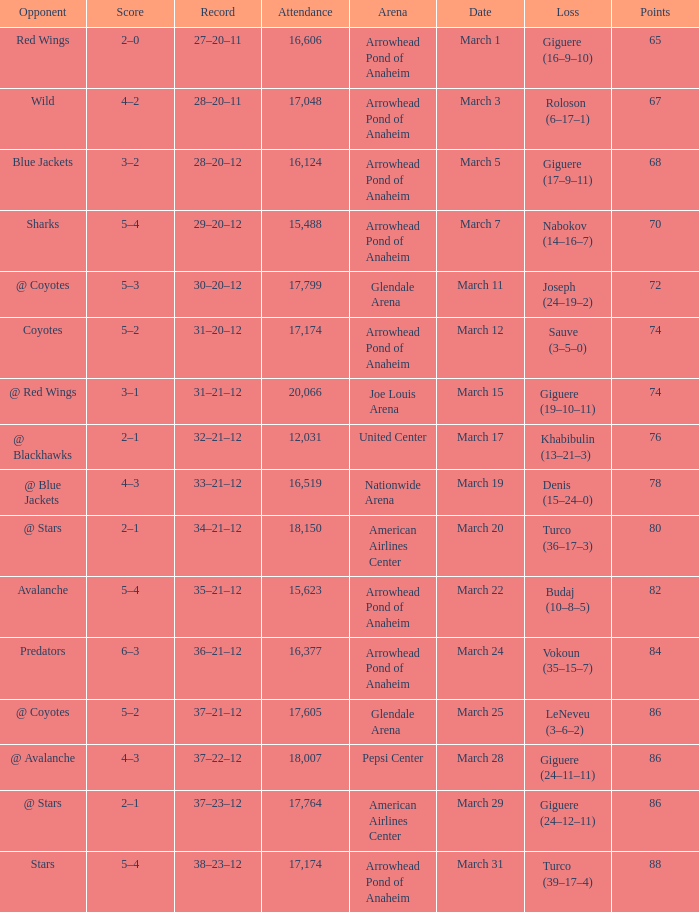What is the Attendance of the game with a Record of 37–21–12 and less than 86 Points? None. 